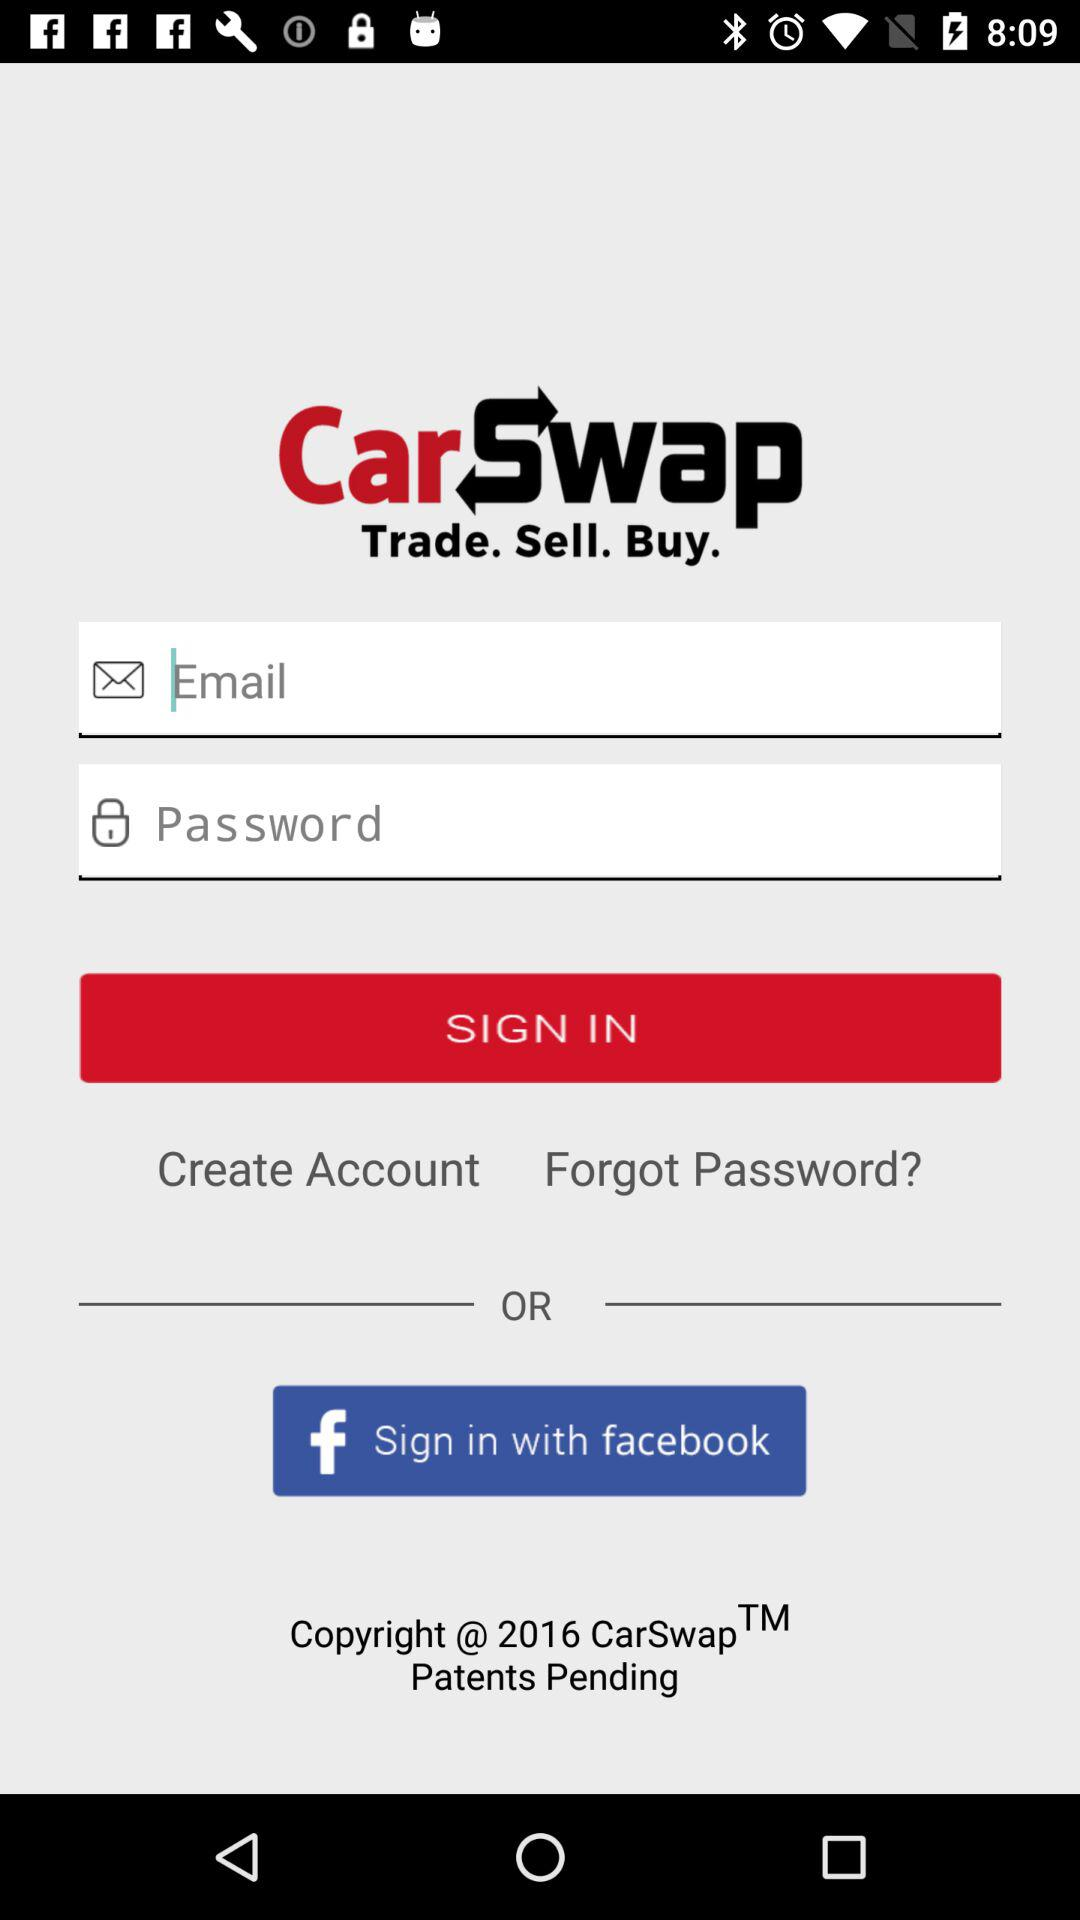Through what application can we sign in? You can sign in through "facebook". 